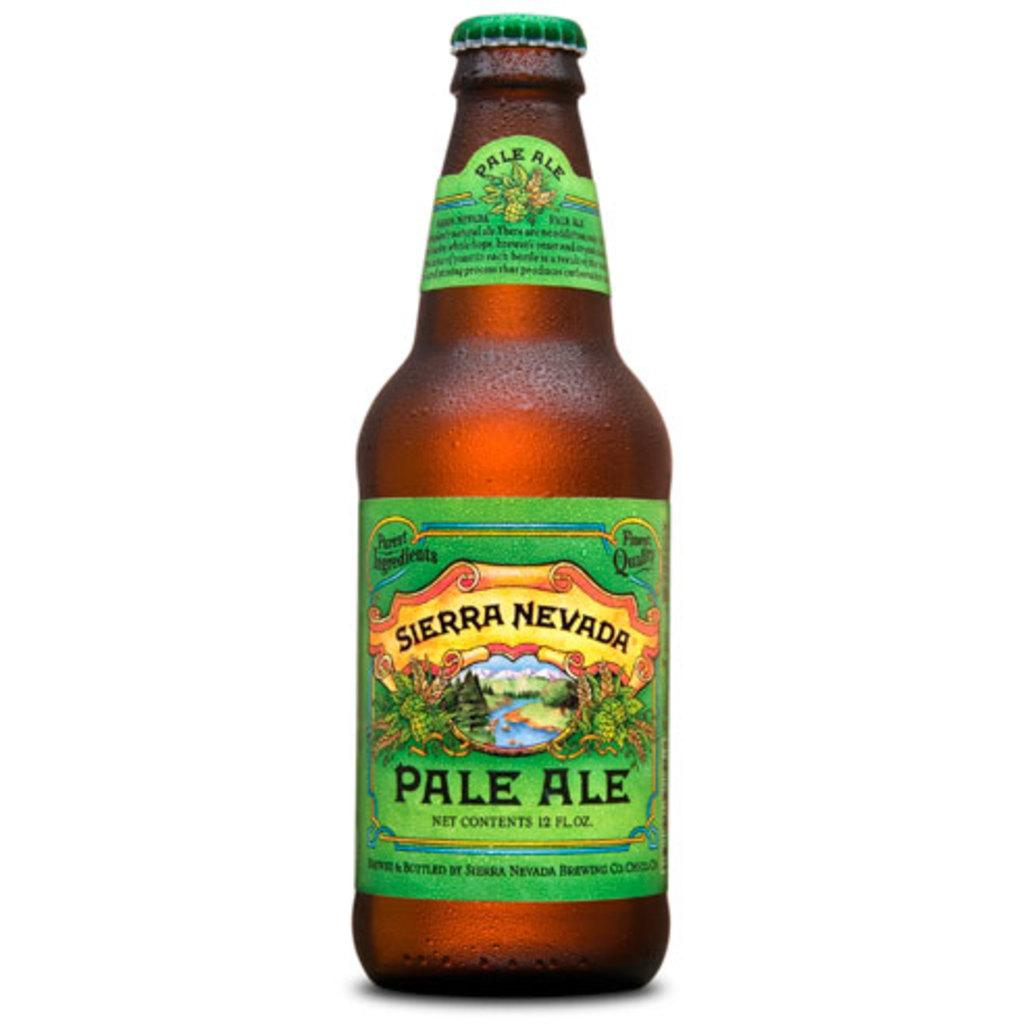<image>
Offer a succinct explanation of the picture presented. Moisture is condensing on the sides of a Sierra Nevada Pale Ale bottle. 